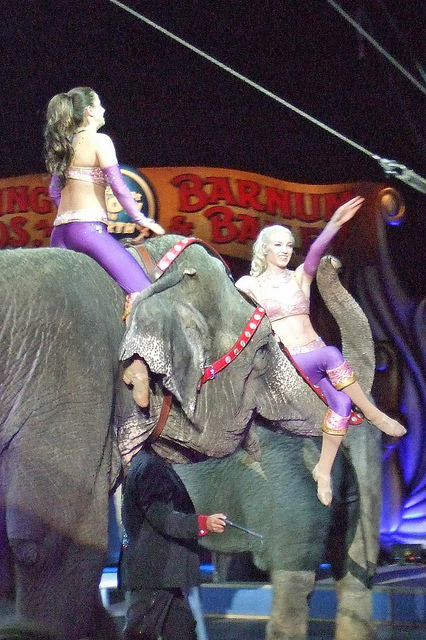Read and extract the text from this image. BARNUM BARNUM NG S 